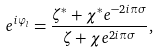<formula> <loc_0><loc_0><loc_500><loc_500>e ^ { i \varphi _ { l } } = \frac { \zeta ^ { \ast } + \chi ^ { \ast } e ^ { - 2 i \pi \sigma } } { \zeta + \chi e ^ { 2 i \pi \sigma } } ,</formula> 